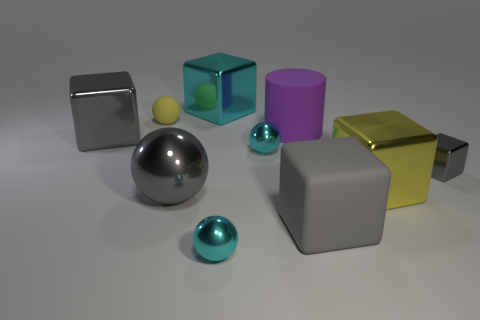Are there any cyan shiny things that have the same shape as the yellow matte object?
Give a very brief answer. Yes. Does the small cube have the same color as the matte block?
Offer a very short reply. Yes. What is the yellow object on the left side of the yellow thing that is to the right of the large purple rubber object made of?
Offer a terse response. Rubber. The yellow metal cube has what size?
Keep it short and to the point. Large. What size is the gray thing that is the same material as the big purple cylinder?
Ensure brevity in your answer.  Large. Is the size of the cyan sphere in front of the gray ball the same as the large yellow block?
Offer a terse response. No. What shape is the shiny thing that is on the left side of the yellow object that is on the left side of the small cyan object that is in front of the small gray thing?
Your answer should be compact. Cube. What number of things are either large yellow metallic objects or big yellow cubes that are on the right side of the large cylinder?
Offer a terse response. 1. There is a cube that is right of the yellow shiny cube; how big is it?
Offer a very short reply. Small. The metal object that is the same color as the small matte sphere is what shape?
Give a very brief answer. Cube. 